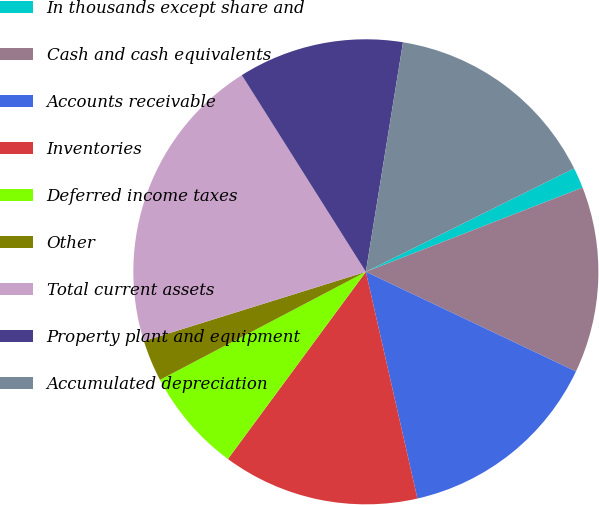Convert chart. <chart><loc_0><loc_0><loc_500><loc_500><pie_chart><fcel>In thousands except share and<fcel>Cash and cash equivalents<fcel>Accounts receivable<fcel>Inventories<fcel>Deferred income taxes<fcel>Other<fcel>Total current assets<fcel>Property plant and equipment<fcel>Accumulated depreciation<nl><fcel>1.44%<fcel>12.95%<fcel>14.39%<fcel>13.67%<fcel>7.2%<fcel>2.88%<fcel>20.86%<fcel>11.51%<fcel>15.11%<nl></chart> 